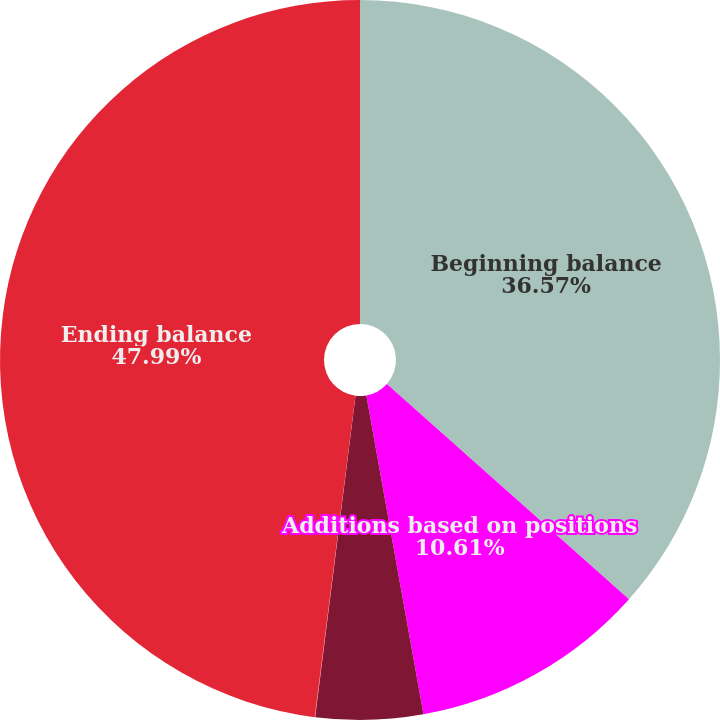Convert chart. <chart><loc_0><loc_0><loc_500><loc_500><pie_chart><fcel>Beginning balance<fcel>Additions based on positions<fcel>Additions for tax positions in<fcel>Reductions for tax positions<fcel>Ending balance<nl><fcel>36.57%<fcel>10.61%<fcel>4.81%<fcel>0.02%<fcel>47.99%<nl></chart> 